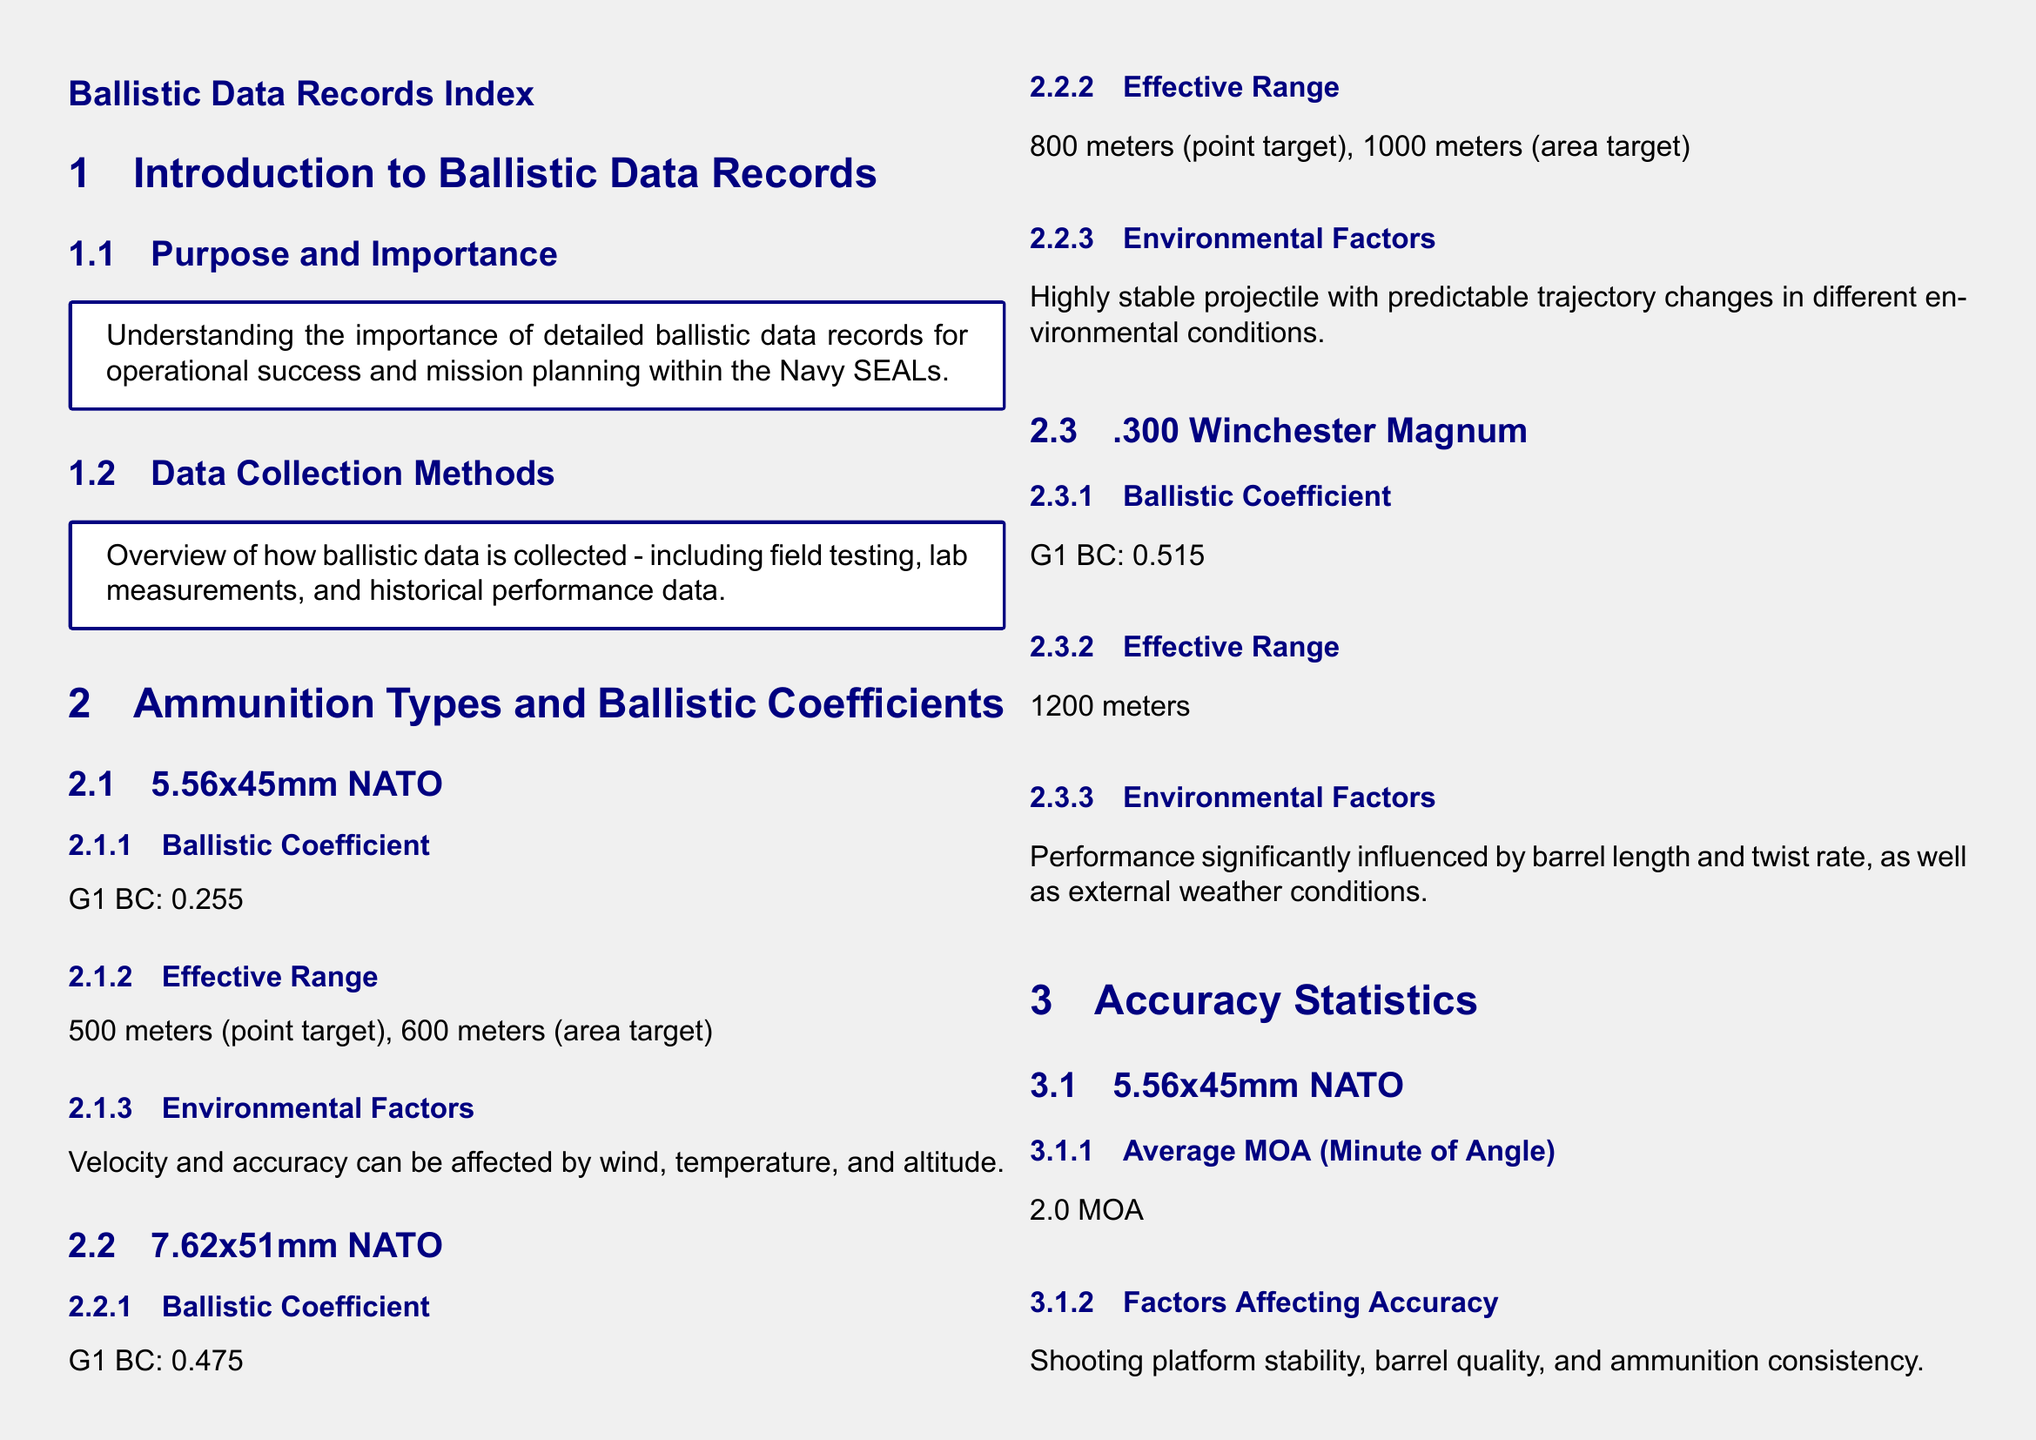what is the G1 BC of 5.56x45mm NATO? The G1 ballistic coefficient for 5.56x45mm NATO is provided in the document.
Answer: 0.255 what is the effective range for 7.62x51mm NATO as a point target? The effective range as a point target for 7.62x51mm NATO is mentioned in the document.
Answer: 800 meters how does barrel length affect .300 Winchester Magnum performance? The performance of .300 Winchester Magnum is influenced by several factors including barrel length.
Answer: Significantly influenced what is the average MOA for 5.56x45mm NATO? The document states the average MOA for 5.56x45mm NATO.
Answer: 2.0 MOA what factors affect the accuracy of 7.62x51mm NATO? The document lists factors affecting the accuracy of 7.62x51mm NATO rifle.
Answer: Shooter skill, sighting system quality, environmental conditions how is ballistic data used in mission preparation? The document includes details on how ballistic data informs mission preparation.
Answer: Pre-mission briefings what is the effective range of .300 Winchester Magnum? The document provides the effective range for .300 Winchester Magnum.
Answer: 1200 meters what is the average MOA for .300 Winchester Magnum? The average MOA for .300 Winchester Magnum is detailed in the document.
Answer: 1.0 MOA what does the document say about data collection methods? The document explains the overview of data collection methods.
Answer: Field testing, lab measurements, historical performance data 